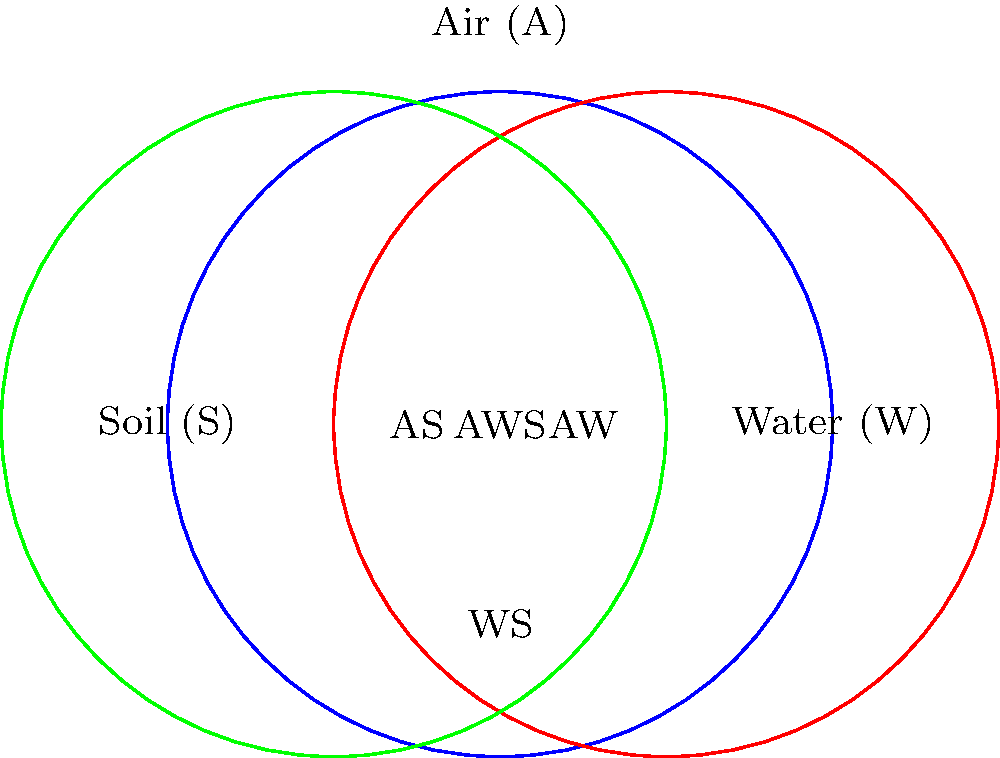The Venn diagram above represents different sources of industrial pollution: Air (A), Water (W), and Soil (S). Each region in the diagram represents a unique combination of pollution sources. How many elements are in the group formed by these pollution sources and their combinations, including the empty set (no pollution)? To determine the order of the group, we need to count all possible combinations of pollution sources:

1. Individual sources: A, W, S (3 elements)
2. Combinations of two sources: AW, AS, WS (3 elements)
3. Combination of all three sources: AWS (1 element)
4. Empty set (no pollution): ∅ (1 element)

The total number of elements in the group is the sum of all these combinations:

$$ 3 + 3 + 1 + 1 = 8 $$

Therefore, the order of the group is 8. This group is isomorphic to the power set of a 3-element set, which forms a group under the symmetric difference operation. In group theory, this is known as the elementary abelian group of order $2^3$.
Answer: 8 